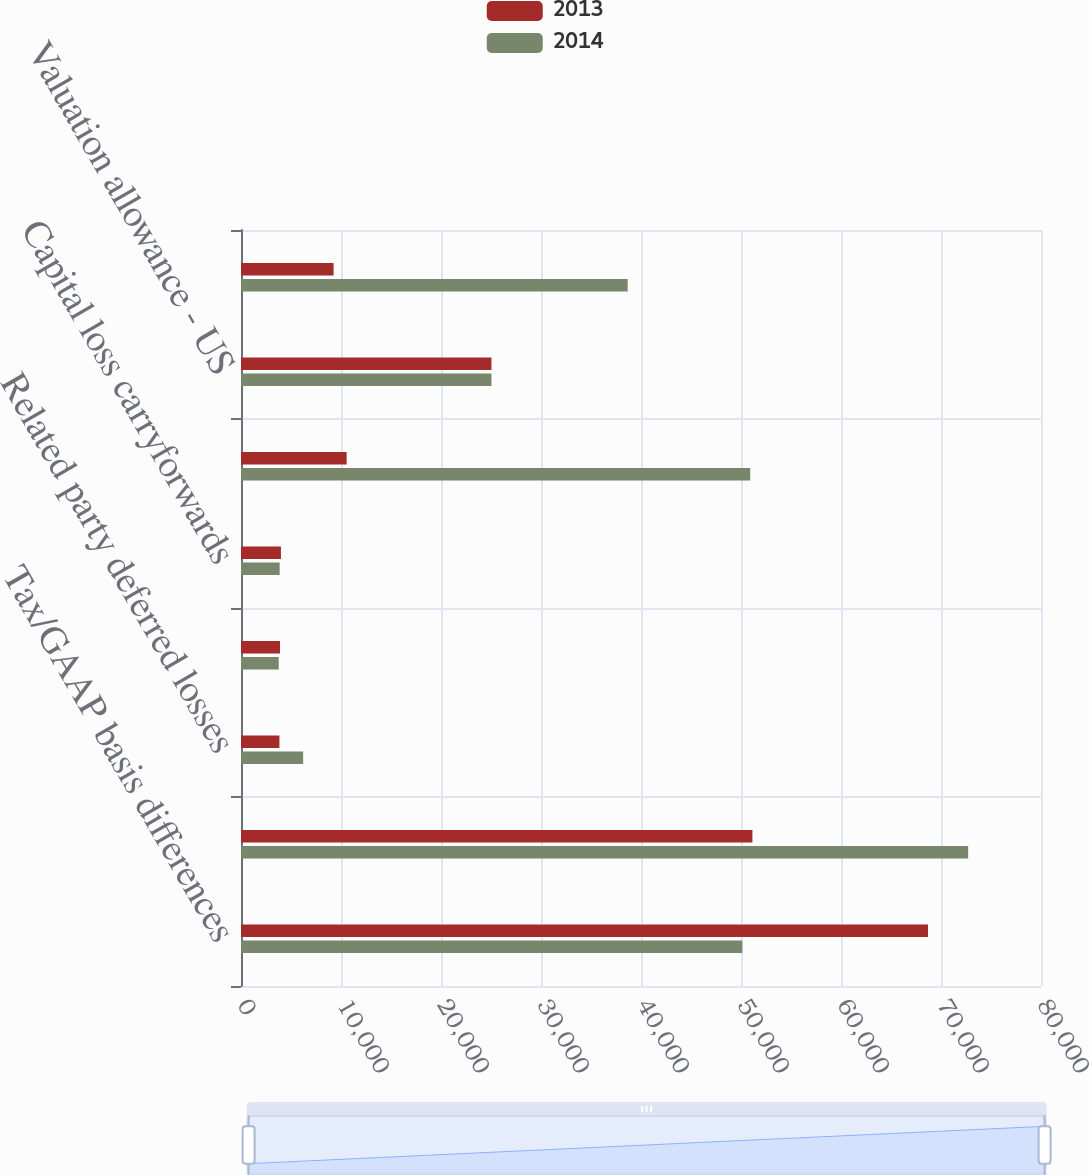Convert chart to OTSL. <chart><loc_0><loc_0><loc_500><loc_500><stacked_bar_chart><ecel><fcel>Tax/GAAP basis differences<fcel>Net operating losses<fcel>Related party deferred losses<fcel>Tax credit carryforwards<fcel>Capital loss carryforwards<fcel>Non-US tax/GAAP basis<fcel>Valuation allowance - US<fcel>Valuation allowance - Non-US<nl><fcel>2013<fcel>68702<fcel>51142<fcel>3843<fcel>3899<fcel>3995<fcel>10566<fcel>25045<fcel>9257<nl><fcel>2014<fcel>50133<fcel>72716<fcel>6214<fcel>3773<fcel>3867<fcel>50920<fcel>25045<fcel>38667<nl></chart> 